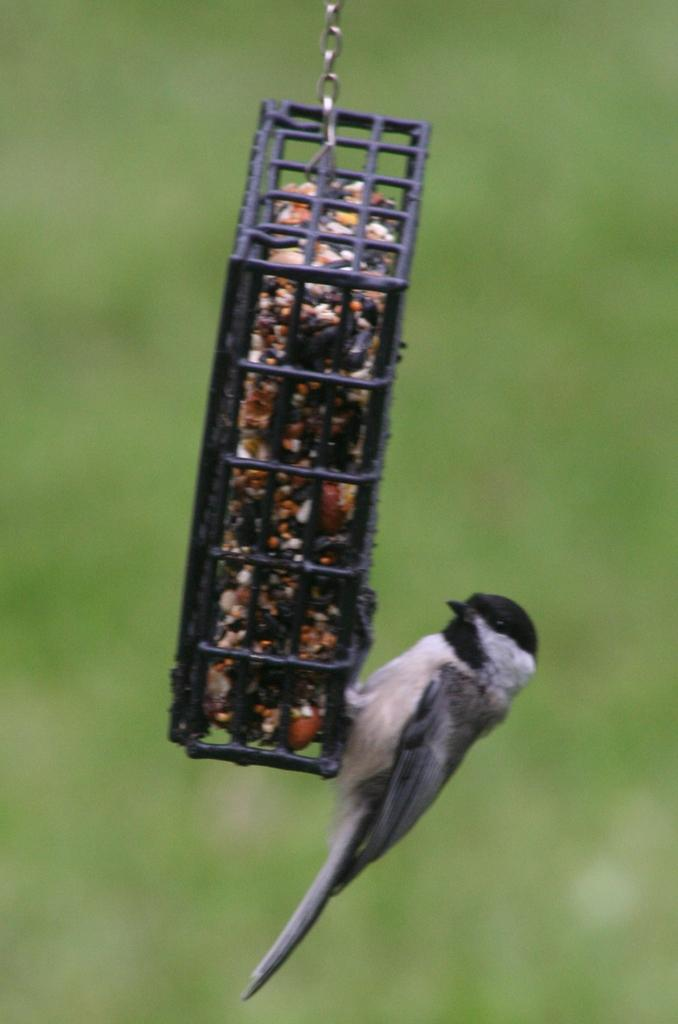What is located in the middle of the image? There is a mesh in the middle of the image. What can be found inside the mesh? There is an object inside the mesh. How is the object connected to the mesh? The object is attached to a chain. What is present on the chain? There is a bird on the chain. What color is predominant in the background of the image? The background of the image is green. Reasoning: Let' Let's think step by step in order to produce the conversation. We start by identifying the main subject in the image, which is the mesh. Then, we expand the conversation to include other items that are also visible, such as the object inside the mesh, the chain, the bird, and the green background. Each question is designed to elicit a specific detail about the image that is known from the provided facts. Absurd Question/Answer: What time of day is it in the image? The time of day is not mentioned or depicted in the image, so it cannot be determined. What unit of measurement is used to describe the air in the image? There is no mention of air or any unit of measurement in the image, so it cannot be determined. 